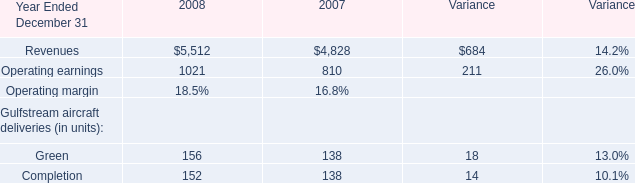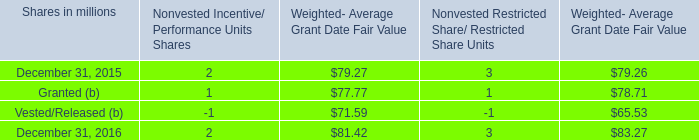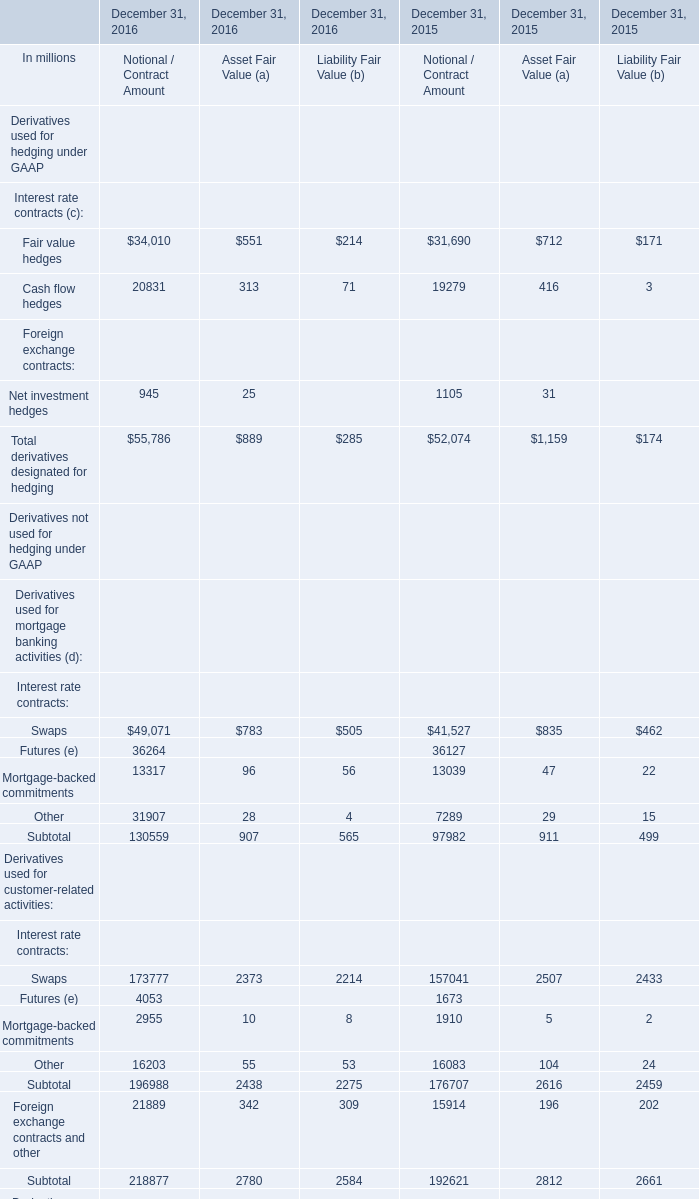what was the total intrinsic value of incentive/performance unit and restricted share/ restricted share unit awards vested during 2016 , 2015 and 2014 in billions? 
Computations: ((.1 + .2) + .1)
Answer: 0.4. 